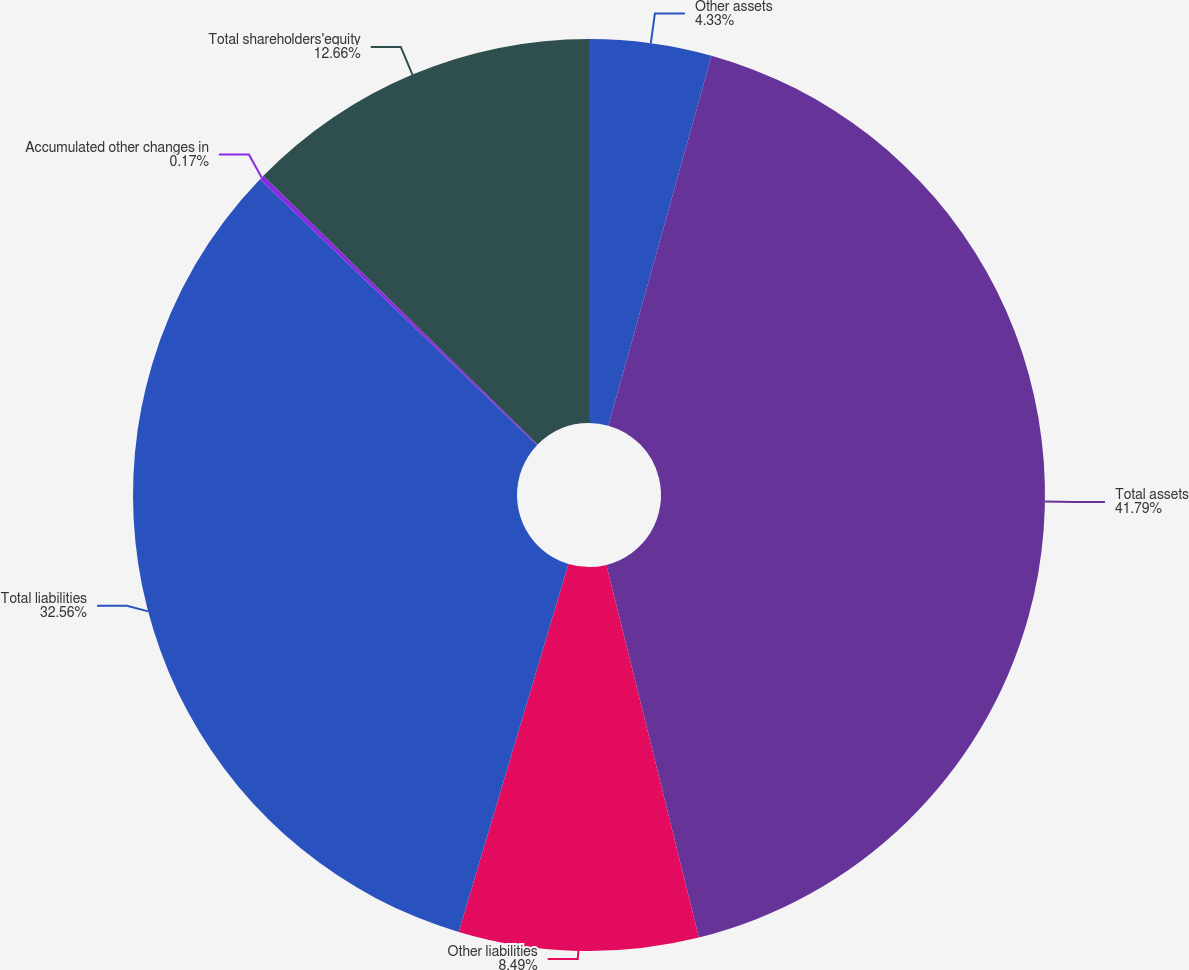Convert chart. <chart><loc_0><loc_0><loc_500><loc_500><pie_chart><fcel>Other assets<fcel>Total assets<fcel>Other liabilities<fcel>Total liabilities<fcel>Accumulated other changes in<fcel>Total shareholders'equity<nl><fcel>4.33%<fcel>41.8%<fcel>8.49%<fcel>32.56%<fcel>0.17%<fcel>12.66%<nl></chart> 